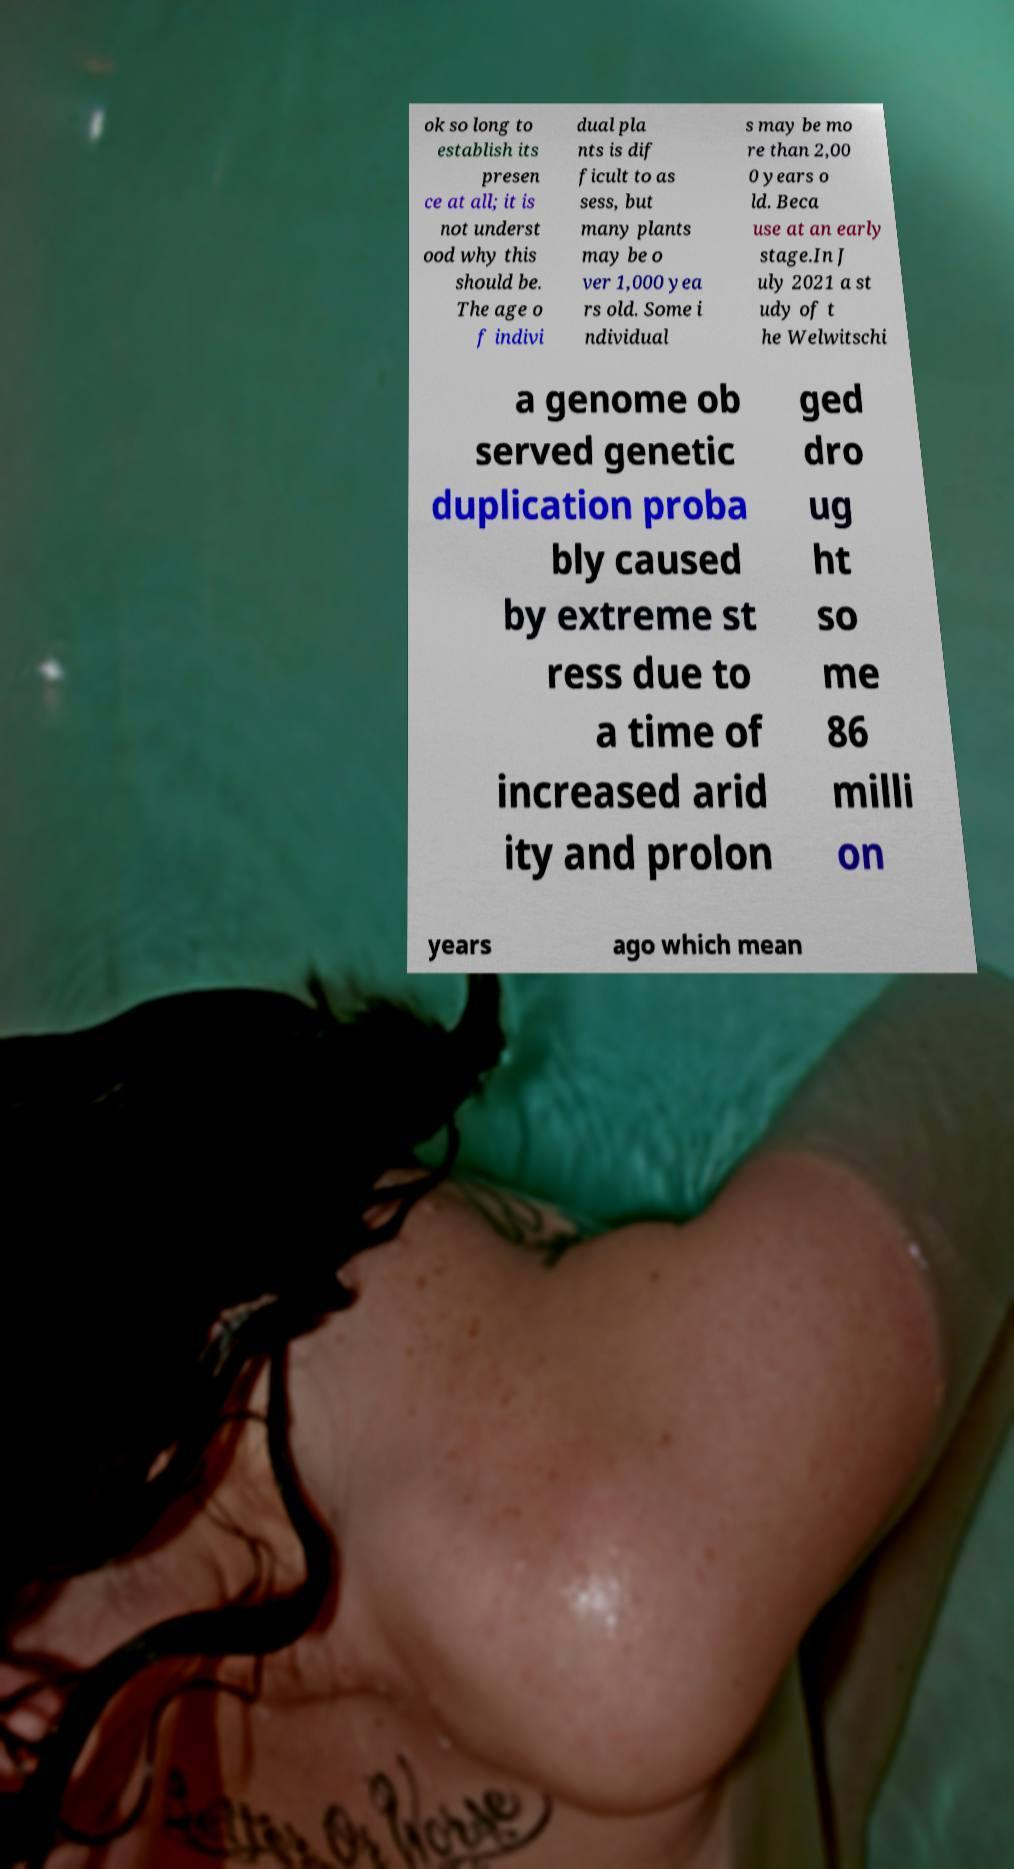Please identify and transcribe the text found in this image. ok so long to establish its presen ce at all; it is not underst ood why this should be. The age o f indivi dual pla nts is dif ficult to as sess, but many plants may be o ver 1,000 yea rs old. Some i ndividual s may be mo re than 2,00 0 years o ld. Beca use at an early stage.In J uly 2021 a st udy of t he Welwitschi a genome ob served genetic duplication proba bly caused by extreme st ress due to a time of increased arid ity and prolon ged dro ug ht so me 86 milli on years ago which mean 